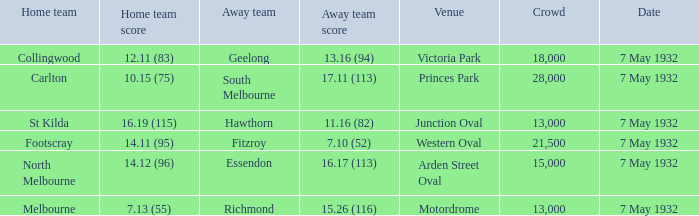11 (83)? Geelong. I'm looking to parse the entire table for insights. Could you assist me with that? {'header': ['Home team', 'Home team score', 'Away team', 'Away team score', 'Venue', 'Crowd', 'Date'], 'rows': [['Collingwood', '12.11 (83)', 'Geelong', '13.16 (94)', 'Victoria Park', '18,000', '7 May 1932'], ['Carlton', '10.15 (75)', 'South Melbourne', '17.11 (113)', 'Princes Park', '28,000', '7 May 1932'], ['St Kilda', '16.19 (115)', 'Hawthorn', '11.16 (82)', 'Junction Oval', '13,000', '7 May 1932'], ['Footscray', '14.11 (95)', 'Fitzroy', '7.10 (52)', 'Western Oval', '21,500', '7 May 1932'], ['North Melbourne', '14.12 (96)', 'Essendon', '16.17 (113)', 'Arden Street Oval', '15,000', '7 May 1932'], ['Melbourne', '7.13 (55)', 'Richmond', '15.26 (116)', 'Motordrome', '13,000', '7 May 1932']]} 